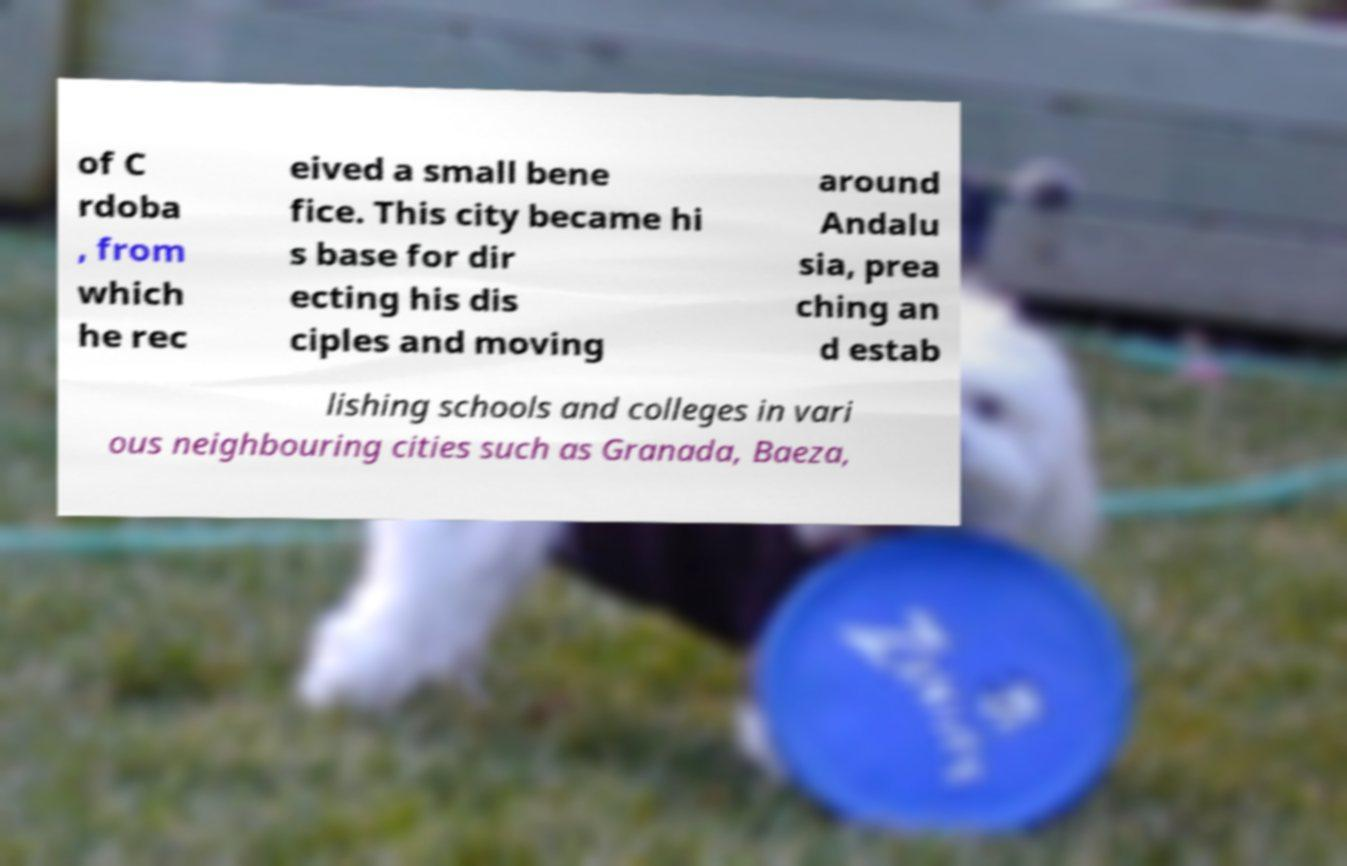Could you extract and type out the text from this image? of C rdoba , from which he rec eived a small bene fice. This city became hi s base for dir ecting his dis ciples and moving around Andalu sia, prea ching an d estab lishing schools and colleges in vari ous neighbouring cities such as Granada, Baeza, 